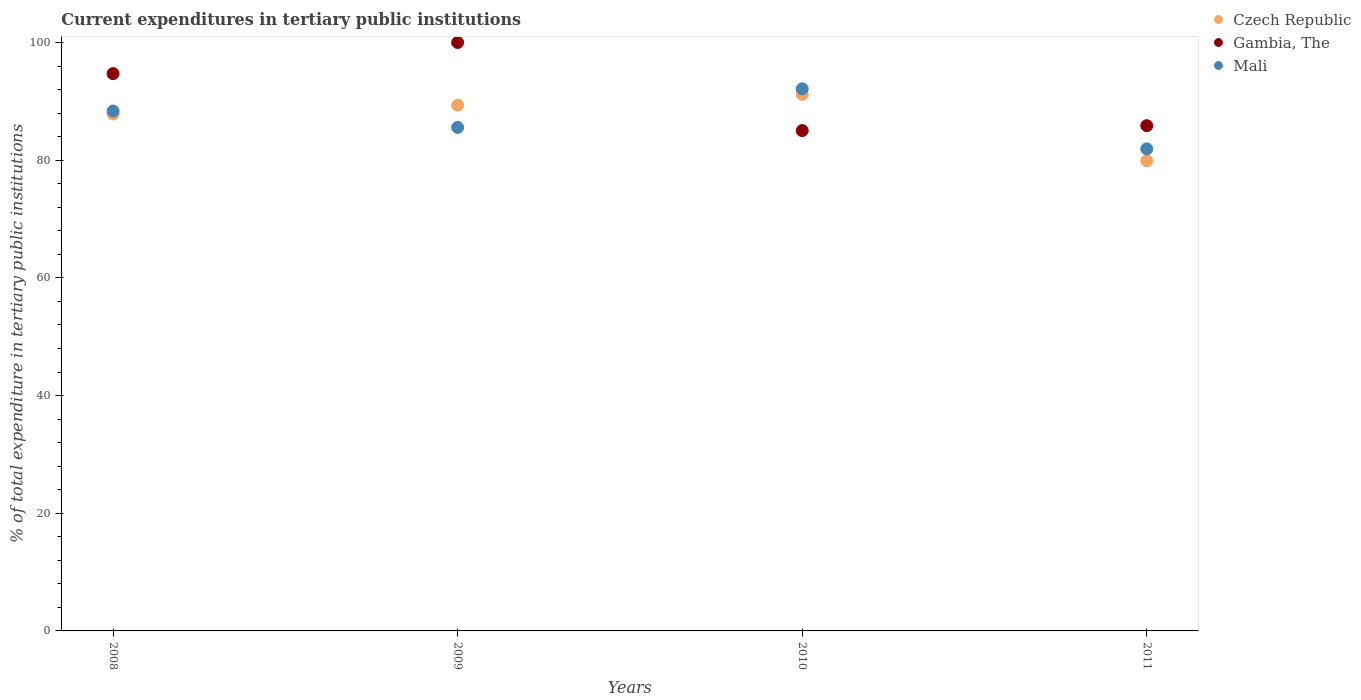What is the current expenditures in tertiary public institutions in Czech Republic in 2010?
Offer a terse response. 91.18. Across all years, what is the minimum current expenditures in tertiary public institutions in Mali?
Ensure brevity in your answer.  81.92. In which year was the current expenditures in tertiary public institutions in Mali maximum?
Give a very brief answer. 2010. What is the total current expenditures in tertiary public institutions in Czech Republic in the graph?
Provide a succinct answer. 348.27. What is the difference between the current expenditures in tertiary public institutions in Mali in 2009 and that in 2010?
Make the answer very short. -6.56. What is the difference between the current expenditures in tertiary public institutions in Czech Republic in 2011 and the current expenditures in tertiary public institutions in Mali in 2010?
Your answer should be very brief. -12.23. What is the average current expenditures in tertiary public institutions in Czech Republic per year?
Your answer should be very brief. 87.07. In the year 2011, what is the difference between the current expenditures in tertiary public institutions in Gambia, The and current expenditures in tertiary public institutions in Mali?
Provide a short and direct response. 3.93. What is the ratio of the current expenditures in tertiary public institutions in Gambia, The in 2009 to that in 2011?
Keep it short and to the point. 1.16. Is the difference between the current expenditures in tertiary public institutions in Gambia, The in 2009 and 2010 greater than the difference between the current expenditures in tertiary public institutions in Mali in 2009 and 2010?
Your response must be concise. Yes. What is the difference between the highest and the second highest current expenditures in tertiary public institutions in Mali?
Provide a short and direct response. 3.77. What is the difference between the highest and the lowest current expenditures in tertiary public institutions in Gambia, The?
Make the answer very short. 14.97. Is the sum of the current expenditures in tertiary public institutions in Czech Republic in 2009 and 2011 greater than the maximum current expenditures in tertiary public institutions in Mali across all years?
Provide a succinct answer. Yes. Is it the case that in every year, the sum of the current expenditures in tertiary public institutions in Mali and current expenditures in tertiary public institutions in Czech Republic  is greater than the current expenditures in tertiary public institutions in Gambia, The?
Provide a short and direct response. Yes. Does the current expenditures in tertiary public institutions in Gambia, The monotonically increase over the years?
Your response must be concise. No. What is the difference between two consecutive major ticks on the Y-axis?
Your answer should be compact. 20. Are the values on the major ticks of Y-axis written in scientific E-notation?
Ensure brevity in your answer.  No. Does the graph contain any zero values?
Keep it short and to the point. No. How many legend labels are there?
Your answer should be very brief. 3. How are the legend labels stacked?
Your answer should be compact. Vertical. What is the title of the graph?
Your response must be concise. Current expenditures in tertiary public institutions. Does "Maldives" appear as one of the legend labels in the graph?
Provide a short and direct response. No. What is the label or title of the X-axis?
Your answer should be very brief. Years. What is the label or title of the Y-axis?
Make the answer very short. % of total expenditure in tertiary public institutions. What is the % of total expenditure in tertiary public institutions in Czech Republic in 2008?
Offer a terse response. 87.84. What is the % of total expenditure in tertiary public institutions in Gambia, The in 2008?
Offer a very short reply. 94.71. What is the % of total expenditure in tertiary public institutions in Mali in 2008?
Your response must be concise. 88.36. What is the % of total expenditure in tertiary public institutions in Czech Republic in 2009?
Your response must be concise. 89.35. What is the % of total expenditure in tertiary public institutions of Mali in 2009?
Ensure brevity in your answer.  85.57. What is the % of total expenditure in tertiary public institutions of Czech Republic in 2010?
Your response must be concise. 91.18. What is the % of total expenditure in tertiary public institutions in Gambia, The in 2010?
Ensure brevity in your answer.  85.03. What is the % of total expenditure in tertiary public institutions of Mali in 2010?
Make the answer very short. 92.13. What is the % of total expenditure in tertiary public institutions of Czech Republic in 2011?
Offer a very short reply. 79.9. What is the % of total expenditure in tertiary public institutions of Gambia, The in 2011?
Your response must be concise. 85.86. What is the % of total expenditure in tertiary public institutions of Mali in 2011?
Make the answer very short. 81.92. Across all years, what is the maximum % of total expenditure in tertiary public institutions of Czech Republic?
Provide a short and direct response. 91.18. Across all years, what is the maximum % of total expenditure in tertiary public institutions in Mali?
Your answer should be very brief. 92.13. Across all years, what is the minimum % of total expenditure in tertiary public institutions in Czech Republic?
Ensure brevity in your answer.  79.9. Across all years, what is the minimum % of total expenditure in tertiary public institutions in Gambia, The?
Give a very brief answer. 85.03. Across all years, what is the minimum % of total expenditure in tertiary public institutions of Mali?
Give a very brief answer. 81.92. What is the total % of total expenditure in tertiary public institutions of Czech Republic in the graph?
Your answer should be very brief. 348.27. What is the total % of total expenditure in tertiary public institutions in Gambia, The in the graph?
Keep it short and to the point. 365.59. What is the total % of total expenditure in tertiary public institutions in Mali in the graph?
Your answer should be compact. 347.98. What is the difference between the % of total expenditure in tertiary public institutions of Czech Republic in 2008 and that in 2009?
Make the answer very short. -1.51. What is the difference between the % of total expenditure in tertiary public institutions of Gambia, The in 2008 and that in 2009?
Make the answer very short. -5.29. What is the difference between the % of total expenditure in tertiary public institutions in Mali in 2008 and that in 2009?
Give a very brief answer. 2.79. What is the difference between the % of total expenditure in tertiary public institutions of Czech Republic in 2008 and that in 2010?
Make the answer very short. -3.35. What is the difference between the % of total expenditure in tertiary public institutions of Gambia, The in 2008 and that in 2010?
Provide a succinct answer. 9.68. What is the difference between the % of total expenditure in tertiary public institutions of Mali in 2008 and that in 2010?
Your answer should be very brief. -3.77. What is the difference between the % of total expenditure in tertiary public institutions of Czech Republic in 2008 and that in 2011?
Your answer should be very brief. 7.94. What is the difference between the % of total expenditure in tertiary public institutions in Gambia, The in 2008 and that in 2011?
Your answer should be compact. 8.85. What is the difference between the % of total expenditure in tertiary public institutions of Mali in 2008 and that in 2011?
Give a very brief answer. 6.43. What is the difference between the % of total expenditure in tertiary public institutions of Czech Republic in 2009 and that in 2010?
Keep it short and to the point. -1.84. What is the difference between the % of total expenditure in tertiary public institutions of Gambia, The in 2009 and that in 2010?
Make the answer very short. 14.97. What is the difference between the % of total expenditure in tertiary public institutions in Mali in 2009 and that in 2010?
Your answer should be compact. -6.56. What is the difference between the % of total expenditure in tertiary public institutions in Czech Republic in 2009 and that in 2011?
Keep it short and to the point. 9.45. What is the difference between the % of total expenditure in tertiary public institutions in Gambia, The in 2009 and that in 2011?
Ensure brevity in your answer.  14.14. What is the difference between the % of total expenditure in tertiary public institutions in Mali in 2009 and that in 2011?
Provide a short and direct response. 3.65. What is the difference between the % of total expenditure in tertiary public institutions in Czech Republic in 2010 and that in 2011?
Provide a short and direct response. 11.28. What is the difference between the % of total expenditure in tertiary public institutions in Gambia, The in 2010 and that in 2011?
Provide a short and direct response. -0.83. What is the difference between the % of total expenditure in tertiary public institutions of Mali in 2010 and that in 2011?
Offer a very short reply. 10.21. What is the difference between the % of total expenditure in tertiary public institutions in Czech Republic in 2008 and the % of total expenditure in tertiary public institutions in Gambia, The in 2009?
Your answer should be compact. -12.16. What is the difference between the % of total expenditure in tertiary public institutions in Czech Republic in 2008 and the % of total expenditure in tertiary public institutions in Mali in 2009?
Make the answer very short. 2.27. What is the difference between the % of total expenditure in tertiary public institutions in Gambia, The in 2008 and the % of total expenditure in tertiary public institutions in Mali in 2009?
Keep it short and to the point. 9.14. What is the difference between the % of total expenditure in tertiary public institutions of Czech Republic in 2008 and the % of total expenditure in tertiary public institutions of Gambia, The in 2010?
Keep it short and to the point. 2.81. What is the difference between the % of total expenditure in tertiary public institutions in Czech Republic in 2008 and the % of total expenditure in tertiary public institutions in Mali in 2010?
Provide a short and direct response. -4.29. What is the difference between the % of total expenditure in tertiary public institutions in Gambia, The in 2008 and the % of total expenditure in tertiary public institutions in Mali in 2010?
Your response must be concise. 2.58. What is the difference between the % of total expenditure in tertiary public institutions of Czech Republic in 2008 and the % of total expenditure in tertiary public institutions of Gambia, The in 2011?
Provide a succinct answer. 1.98. What is the difference between the % of total expenditure in tertiary public institutions of Czech Republic in 2008 and the % of total expenditure in tertiary public institutions of Mali in 2011?
Keep it short and to the point. 5.91. What is the difference between the % of total expenditure in tertiary public institutions in Gambia, The in 2008 and the % of total expenditure in tertiary public institutions in Mali in 2011?
Ensure brevity in your answer.  12.78. What is the difference between the % of total expenditure in tertiary public institutions of Czech Republic in 2009 and the % of total expenditure in tertiary public institutions of Gambia, The in 2010?
Offer a very short reply. 4.32. What is the difference between the % of total expenditure in tertiary public institutions of Czech Republic in 2009 and the % of total expenditure in tertiary public institutions of Mali in 2010?
Keep it short and to the point. -2.78. What is the difference between the % of total expenditure in tertiary public institutions in Gambia, The in 2009 and the % of total expenditure in tertiary public institutions in Mali in 2010?
Provide a succinct answer. 7.87. What is the difference between the % of total expenditure in tertiary public institutions of Czech Republic in 2009 and the % of total expenditure in tertiary public institutions of Gambia, The in 2011?
Your answer should be very brief. 3.49. What is the difference between the % of total expenditure in tertiary public institutions of Czech Republic in 2009 and the % of total expenditure in tertiary public institutions of Mali in 2011?
Offer a very short reply. 7.42. What is the difference between the % of total expenditure in tertiary public institutions in Gambia, The in 2009 and the % of total expenditure in tertiary public institutions in Mali in 2011?
Make the answer very short. 18.08. What is the difference between the % of total expenditure in tertiary public institutions of Czech Republic in 2010 and the % of total expenditure in tertiary public institutions of Gambia, The in 2011?
Give a very brief answer. 5.33. What is the difference between the % of total expenditure in tertiary public institutions of Czech Republic in 2010 and the % of total expenditure in tertiary public institutions of Mali in 2011?
Your answer should be very brief. 9.26. What is the difference between the % of total expenditure in tertiary public institutions of Gambia, The in 2010 and the % of total expenditure in tertiary public institutions of Mali in 2011?
Your answer should be very brief. 3.1. What is the average % of total expenditure in tertiary public institutions of Czech Republic per year?
Keep it short and to the point. 87.07. What is the average % of total expenditure in tertiary public institutions of Gambia, The per year?
Provide a short and direct response. 91.4. What is the average % of total expenditure in tertiary public institutions in Mali per year?
Make the answer very short. 86.99. In the year 2008, what is the difference between the % of total expenditure in tertiary public institutions in Czech Republic and % of total expenditure in tertiary public institutions in Gambia, The?
Offer a very short reply. -6.87. In the year 2008, what is the difference between the % of total expenditure in tertiary public institutions of Czech Republic and % of total expenditure in tertiary public institutions of Mali?
Your answer should be very brief. -0.52. In the year 2008, what is the difference between the % of total expenditure in tertiary public institutions in Gambia, The and % of total expenditure in tertiary public institutions in Mali?
Provide a short and direct response. 6.35. In the year 2009, what is the difference between the % of total expenditure in tertiary public institutions of Czech Republic and % of total expenditure in tertiary public institutions of Gambia, The?
Your answer should be compact. -10.65. In the year 2009, what is the difference between the % of total expenditure in tertiary public institutions in Czech Republic and % of total expenditure in tertiary public institutions in Mali?
Your response must be concise. 3.78. In the year 2009, what is the difference between the % of total expenditure in tertiary public institutions of Gambia, The and % of total expenditure in tertiary public institutions of Mali?
Ensure brevity in your answer.  14.43. In the year 2010, what is the difference between the % of total expenditure in tertiary public institutions in Czech Republic and % of total expenditure in tertiary public institutions in Gambia, The?
Your answer should be compact. 6.16. In the year 2010, what is the difference between the % of total expenditure in tertiary public institutions in Czech Republic and % of total expenditure in tertiary public institutions in Mali?
Offer a very short reply. -0.95. In the year 2010, what is the difference between the % of total expenditure in tertiary public institutions in Gambia, The and % of total expenditure in tertiary public institutions in Mali?
Make the answer very short. -7.1. In the year 2011, what is the difference between the % of total expenditure in tertiary public institutions in Czech Republic and % of total expenditure in tertiary public institutions in Gambia, The?
Your response must be concise. -5.95. In the year 2011, what is the difference between the % of total expenditure in tertiary public institutions in Czech Republic and % of total expenditure in tertiary public institutions in Mali?
Provide a succinct answer. -2.02. In the year 2011, what is the difference between the % of total expenditure in tertiary public institutions of Gambia, The and % of total expenditure in tertiary public institutions of Mali?
Your response must be concise. 3.93. What is the ratio of the % of total expenditure in tertiary public institutions of Czech Republic in 2008 to that in 2009?
Provide a succinct answer. 0.98. What is the ratio of the % of total expenditure in tertiary public institutions in Gambia, The in 2008 to that in 2009?
Your answer should be compact. 0.95. What is the ratio of the % of total expenditure in tertiary public institutions in Mali in 2008 to that in 2009?
Your answer should be compact. 1.03. What is the ratio of the % of total expenditure in tertiary public institutions of Czech Republic in 2008 to that in 2010?
Your response must be concise. 0.96. What is the ratio of the % of total expenditure in tertiary public institutions of Gambia, The in 2008 to that in 2010?
Offer a very short reply. 1.11. What is the ratio of the % of total expenditure in tertiary public institutions in Mali in 2008 to that in 2010?
Make the answer very short. 0.96. What is the ratio of the % of total expenditure in tertiary public institutions in Czech Republic in 2008 to that in 2011?
Give a very brief answer. 1.1. What is the ratio of the % of total expenditure in tertiary public institutions in Gambia, The in 2008 to that in 2011?
Ensure brevity in your answer.  1.1. What is the ratio of the % of total expenditure in tertiary public institutions in Mali in 2008 to that in 2011?
Make the answer very short. 1.08. What is the ratio of the % of total expenditure in tertiary public institutions of Czech Republic in 2009 to that in 2010?
Your response must be concise. 0.98. What is the ratio of the % of total expenditure in tertiary public institutions in Gambia, The in 2009 to that in 2010?
Your answer should be compact. 1.18. What is the ratio of the % of total expenditure in tertiary public institutions in Mali in 2009 to that in 2010?
Make the answer very short. 0.93. What is the ratio of the % of total expenditure in tertiary public institutions in Czech Republic in 2009 to that in 2011?
Your answer should be compact. 1.12. What is the ratio of the % of total expenditure in tertiary public institutions of Gambia, The in 2009 to that in 2011?
Offer a very short reply. 1.16. What is the ratio of the % of total expenditure in tertiary public institutions of Mali in 2009 to that in 2011?
Your answer should be compact. 1.04. What is the ratio of the % of total expenditure in tertiary public institutions in Czech Republic in 2010 to that in 2011?
Keep it short and to the point. 1.14. What is the ratio of the % of total expenditure in tertiary public institutions of Gambia, The in 2010 to that in 2011?
Your answer should be very brief. 0.99. What is the ratio of the % of total expenditure in tertiary public institutions of Mali in 2010 to that in 2011?
Offer a very short reply. 1.12. What is the difference between the highest and the second highest % of total expenditure in tertiary public institutions of Czech Republic?
Make the answer very short. 1.84. What is the difference between the highest and the second highest % of total expenditure in tertiary public institutions in Gambia, The?
Offer a very short reply. 5.29. What is the difference between the highest and the second highest % of total expenditure in tertiary public institutions in Mali?
Your answer should be very brief. 3.77. What is the difference between the highest and the lowest % of total expenditure in tertiary public institutions of Czech Republic?
Your response must be concise. 11.28. What is the difference between the highest and the lowest % of total expenditure in tertiary public institutions of Gambia, The?
Your response must be concise. 14.97. What is the difference between the highest and the lowest % of total expenditure in tertiary public institutions in Mali?
Give a very brief answer. 10.21. 